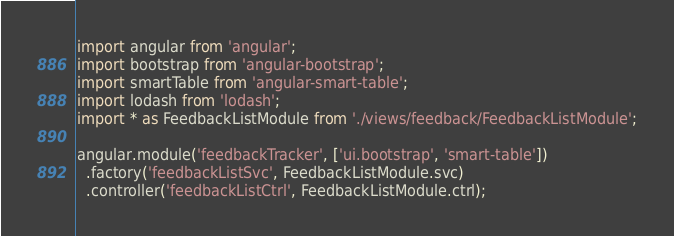Convert code to text. <code><loc_0><loc_0><loc_500><loc_500><_JavaScript_>import angular from 'angular';
import bootstrap from 'angular-bootstrap';
import smartTable from 'angular-smart-table';
import lodash from 'lodash';
import * as FeedbackListModule from './views/feedback/FeedbackListModule';

angular.module('feedbackTracker', ['ui.bootstrap', 'smart-table'])
  .factory('feedbackListSvc', FeedbackListModule.svc)
  .controller('feedbackListCtrl', FeedbackListModule.ctrl);
</code> 